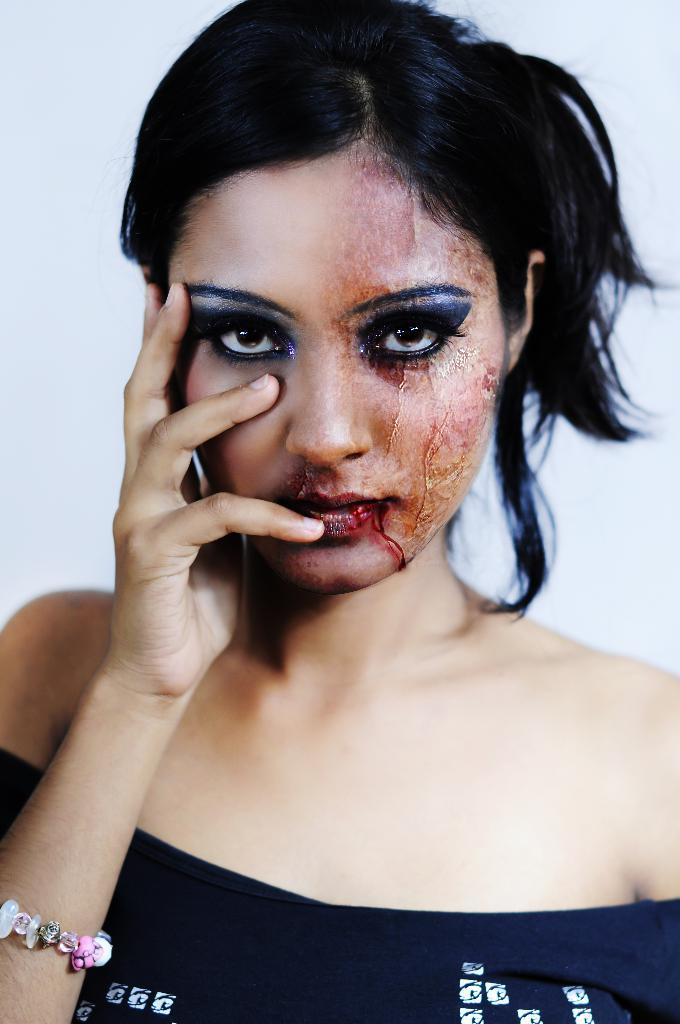Who or what is the main subject in the image? There is a person in the image. What color is the background of the image? The background of the image is white. How many pieces of pie are on the person's plate in the image? There is no plate or pie present in the image; it only features a person with a white background. 